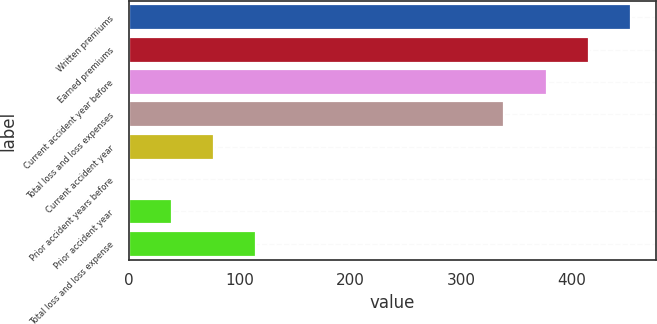<chart> <loc_0><loc_0><loc_500><loc_500><bar_chart><fcel>Written premiums<fcel>Earned premiums<fcel>Current accident year before<fcel>Total loss and loss expenses<fcel>Current accident year<fcel>Prior accident years before<fcel>Prior accident year<fcel>Total loss and loss expense<nl><fcel>453.39<fcel>415.26<fcel>377.13<fcel>339<fcel>76.96<fcel>0.7<fcel>38.83<fcel>115.09<nl></chart> 